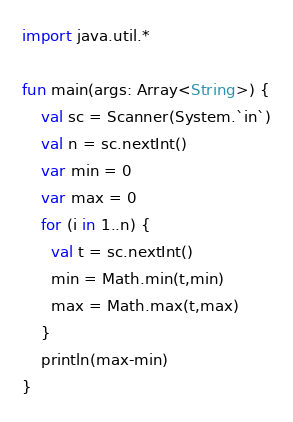Convert code to text. <code><loc_0><loc_0><loc_500><loc_500><_Kotlin_>import java.util.*

fun main(args: Array<String>) {
    val sc = Scanner(System.`in`)
    val n = sc.nextInt()
    var min = 0
    var max = 0
    for (i in 1..n) {
      val t = sc.nextInt()
      min = Math.min(t,min)
      max = Math.max(t,max)
    }
    println(max-min)
}
</code> 